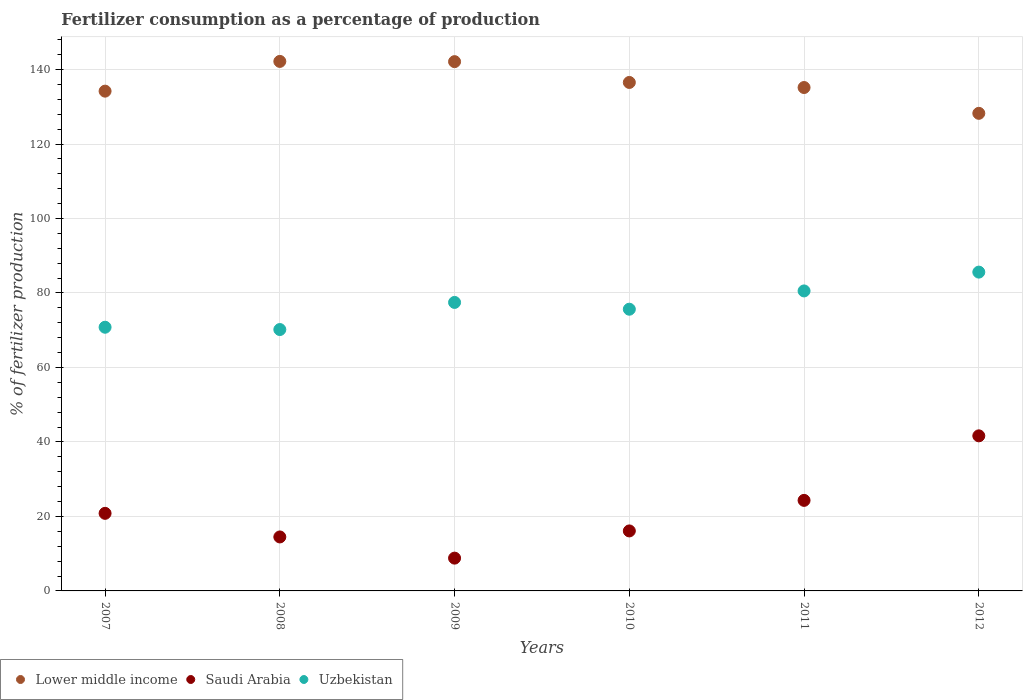Is the number of dotlines equal to the number of legend labels?
Offer a very short reply. Yes. What is the percentage of fertilizers consumed in Uzbekistan in 2008?
Your answer should be very brief. 70.18. Across all years, what is the maximum percentage of fertilizers consumed in Lower middle income?
Offer a very short reply. 142.18. Across all years, what is the minimum percentage of fertilizers consumed in Saudi Arabia?
Your response must be concise. 8.81. In which year was the percentage of fertilizers consumed in Saudi Arabia maximum?
Provide a succinct answer. 2012. What is the total percentage of fertilizers consumed in Uzbekistan in the graph?
Provide a succinct answer. 460.25. What is the difference between the percentage of fertilizers consumed in Saudi Arabia in 2009 and that in 2011?
Offer a very short reply. -15.51. What is the difference between the percentage of fertilizers consumed in Lower middle income in 2009 and the percentage of fertilizers consumed in Saudi Arabia in 2007?
Provide a short and direct response. 121.29. What is the average percentage of fertilizers consumed in Lower middle income per year?
Provide a succinct answer. 136.4. In the year 2011, what is the difference between the percentage of fertilizers consumed in Uzbekistan and percentage of fertilizers consumed in Saudi Arabia?
Ensure brevity in your answer.  56.24. What is the ratio of the percentage of fertilizers consumed in Saudi Arabia in 2007 to that in 2009?
Your answer should be very brief. 2.37. Is the percentage of fertilizers consumed in Uzbekistan in 2008 less than that in 2009?
Give a very brief answer. Yes. Is the difference between the percentage of fertilizers consumed in Uzbekistan in 2009 and 2010 greater than the difference between the percentage of fertilizers consumed in Saudi Arabia in 2009 and 2010?
Your answer should be compact. Yes. What is the difference between the highest and the second highest percentage of fertilizers consumed in Lower middle income?
Your answer should be compact. 0.06. What is the difference between the highest and the lowest percentage of fertilizers consumed in Lower middle income?
Make the answer very short. 13.94. Is the sum of the percentage of fertilizers consumed in Saudi Arabia in 2007 and 2012 greater than the maximum percentage of fertilizers consumed in Uzbekistan across all years?
Ensure brevity in your answer.  No. How many dotlines are there?
Offer a very short reply. 3. What is the difference between two consecutive major ticks on the Y-axis?
Your answer should be very brief. 20. Are the values on the major ticks of Y-axis written in scientific E-notation?
Provide a succinct answer. No. Does the graph contain grids?
Offer a very short reply. Yes. Where does the legend appear in the graph?
Keep it short and to the point. Bottom left. How many legend labels are there?
Your answer should be compact. 3. What is the title of the graph?
Your answer should be very brief. Fertilizer consumption as a percentage of production. Does "Paraguay" appear as one of the legend labels in the graph?
Provide a short and direct response. No. What is the label or title of the X-axis?
Make the answer very short. Years. What is the label or title of the Y-axis?
Provide a short and direct response. % of fertilizer production. What is the % of fertilizer production of Lower middle income in 2007?
Provide a short and direct response. 134.19. What is the % of fertilizer production of Saudi Arabia in 2007?
Give a very brief answer. 20.83. What is the % of fertilizer production in Uzbekistan in 2007?
Make the answer very short. 70.8. What is the % of fertilizer production in Lower middle income in 2008?
Your response must be concise. 142.18. What is the % of fertilizer production in Saudi Arabia in 2008?
Make the answer very short. 14.49. What is the % of fertilizer production in Uzbekistan in 2008?
Your answer should be very brief. 70.18. What is the % of fertilizer production in Lower middle income in 2009?
Your answer should be compact. 142.12. What is the % of fertilizer production of Saudi Arabia in 2009?
Your answer should be compact. 8.81. What is the % of fertilizer production of Uzbekistan in 2009?
Make the answer very short. 77.46. What is the % of fertilizer production of Lower middle income in 2010?
Provide a succinct answer. 136.53. What is the % of fertilizer production in Saudi Arabia in 2010?
Offer a terse response. 16.11. What is the % of fertilizer production in Uzbekistan in 2010?
Offer a terse response. 75.64. What is the % of fertilizer production in Lower middle income in 2011?
Offer a terse response. 135.17. What is the % of fertilizer production in Saudi Arabia in 2011?
Make the answer very short. 24.31. What is the % of fertilizer production in Uzbekistan in 2011?
Keep it short and to the point. 80.55. What is the % of fertilizer production in Lower middle income in 2012?
Make the answer very short. 128.24. What is the % of fertilizer production in Saudi Arabia in 2012?
Make the answer very short. 41.64. What is the % of fertilizer production in Uzbekistan in 2012?
Your answer should be very brief. 85.6. Across all years, what is the maximum % of fertilizer production of Lower middle income?
Provide a succinct answer. 142.18. Across all years, what is the maximum % of fertilizer production of Saudi Arabia?
Offer a terse response. 41.64. Across all years, what is the maximum % of fertilizer production of Uzbekistan?
Ensure brevity in your answer.  85.6. Across all years, what is the minimum % of fertilizer production in Lower middle income?
Make the answer very short. 128.24. Across all years, what is the minimum % of fertilizer production in Saudi Arabia?
Make the answer very short. 8.81. Across all years, what is the minimum % of fertilizer production in Uzbekistan?
Your response must be concise. 70.18. What is the total % of fertilizer production in Lower middle income in the graph?
Your answer should be very brief. 818.42. What is the total % of fertilizer production in Saudi Arabia in the graph?
Your answer should be compact. 126.19. What is the total % of fertilizer production of Uzbekistan in the graph?
Ensure brevity in your answer.  460.25. What is the difference between the % of fertilizer production in Lower middle income in 2007 and that in 2008?
Your answer should be very brief. -7.98. What is the difference between the % of fertilizer production in Saudi Arabia in 2007 and that in 2008?
Offer a terse response. 6.34. What is the difference between the % of fertilizer production in Uzbekistan in 2007 and that in 2008?
Make the answer very short. 0.62. What is the difference between the % of fertilizer production in Lower middle income in 2007 and that in 2009?
Your answer should be compact. -7.92. What is the difference between the % of fertilizer production in Saudi Arabia in 2007 and that in 2009?
Provide a succinct answer. 12.03. What is the difference between the % of fertilizer production in Uzbekistan in 2007 and that in 2009?
Your answer should be compact. -6.66. What is the difference between the % of fertilizer production of Lower middle income in 2007 and that in 2010?
Give a very brief answer. -2.33. What is the difference between the % of fertilizer production in Saudi Arabia in 2007 and that in 2010?
Provide a short and direct response. 4.72. What is the difference between the % of fertilizer production of Uzbekistan in 2007 and that in 2010?
Keep it short and to the point. -4.84. What is the difference between the % of fertilizer production in Lower middle income in 2007 and that in 2011?
Provide a short and direct response. -0.97. What is the difference between the % of fertilizer production of Saudi Arabia in 2007 and that in 2011?
Ensure brevity in your answer.  -3.48. What is the difference between the % of fertilizer production of Uzbekistan in 2007 and that in 2011?
Keep it short and to the point. -9.75. What is the difference between the % of fertilizer production in Lower middle income in 2007 and that in 2012?
Keep it short and to the point. 5.96. What is the difference between the % of fertilizer production of Saudi Arabia in 2007 and that in 2012?
Provide a short and direct response. -20.81. What is the difference between the % of fertilizer production in Uzbekistan in 2007 and that in 2012?
Make the answer very short. -14.8. What is the difference between the % of fertilizer production in Lower middle income in 2008 and that in 2009?
Your answer should be compact. 0.06. What is the difference between the % of fertilizer production of Saudi Arabia in 2008 and that in 2009?
Provide a succinct answer. 5.69. What is the difference between the % of fertilizer production of Uzbekistan in 2008 and that in 2009?
Give a very brief answer. -7.28. What is the difference between the % of fertilizer production of Lower middle income in 2008 and that in 2010?
Ensure brevity in your answer.  5.65. What is the difference between the % of fertilizer production of Saudi Arabia in 2008 and that in 2010?
Offer a very short reply. -1.62. What is the difference between the % of fertilizer production of Uzbekistan in 2008 and that in 2010?
Offer a very short reply. -5.46. What is the difference between the % of fertilizer production of Lower middle income in 2008 and that in 2011?
Offer a terse response. 7.01. What is the difference between the % of fertilizer production in Saudi Arabia in 2008 and that in 2011?
Provide a succinct answer. -9.82. What is the difference between the % of fertilizer production in Uzbekistan in 2008 and that in 2011?
Your answer should be very brief. -10.37. What is the difference between the % of fertilizer production in Lower middle income in 2008 and that in 2012?
Your answer should be very brief. 13.94. What is the difference between the % of fertilizer production in Saudi Arabia in 2008 and that in 2012?
Ensure brevity in your answer.  -27.15. What is the difference between the % of fertilizer production of Uzbekistan in 2008 and that in 2012?
Offer a terse response. -15.42. What is the difference between the % of fertilizer production in Lower middle income in 2009 and that in 2010?
Offer a terse response. 5.59. What is the difference between the % of fertilizer production of Saudi Arabia in 2009 and that in 2010?
Ensure brevity in your answer.  -7.3. What is the difference between the % of fertilizer production in Uzbekistan in 2009 and that in 2010?
Your answer should be very brief. 1.82. What is the difference between the % of fertilizer production in Lower middle income in 2009 and that in 2011?
Provide a short and direct response. 6.95. What is the difference between the % of fertilizer production of Saudi Arabia in 2009 and that in 2011?
Offer a terse response. -15.51. What is the difference between the % of fertilizer production of Uzbekistan in 2009 and that in 2011?
Your response must be concise. -3.09. What is the difference between the % of fertilizer production in Lower middle income in 2009 and that in 2012?
Provide a short and direct response. 13.88. What is the difference between the % of fertilizer production in Saudi Arabia in 2009 and that in 2012?
Your answer should be very brief. -32.83. What is the difference between the % of fertilizer production of Uzbekistan in 2009 and that in 2012?
Your response must be concise. -8.14. What is the difference between the % of fertilizer production in Lower middle income in 2010 and that in 2011?
Make the answer very short. 1.36. What is the difference between the % of fertilizer production of Saudi Arabia in 2010 and that in 2011?
Offer a very short reply. -8.2. What is the difference between the % of fertilizer production in Uzbekistan in 2010 and that in 2011?
Ensure brevity in your answer.  -4.91. What is the difference between the % of fertilizer production of Lower middle income in 2010 and that in 2012?
Provide a short and direct response. 8.29. What is the difference between the % of fertilizer production in Saudi Arabia in 2010 and that in 2012?
Offer a very short reply. -25.53. What is the difference between the % of fertilizer production in Uzbekistan in 2010 and that in 2012?
Provide a short and direct response. -9.96. What is the difference between the % of fertilizer production of Lower middle income in 2011 and that in 2012?
Provide a succinct answer. 6.93. What is the difference between the % of fertilizer production of Saudi Arabia in 2011 and that in 2012?
Keep it short and to the point. -17.33. What is the difference between the % of fertilizer production of Uzbekistan in 2011 and that in 2012?
Your answer should be very brief. -5.05. What is the difference between the % of fertilizer production of Lower middle income in 2007 and the % of fertilizer production of Saudi Arabia in 2008?
Provide a succinct answer. 119.7. What is the difference between the % of fertilizer production of Lower middle income in 2007 and the % of fertilizer production of Uzbekistan in 2008?
Keep it short and to the point. 64.01. What is the difference between the % of fertilizer production of Saudi Arabia in 2007 and the % of fertilizer production of Uzbekistan in 2008?
Your response must be concise. -49.35. What is the difference between the % of fertilizer production in Lower middle income in 2007 and the % of fertilizer production in Saudi Arabia in 2009?
Ensure brevity in your answer.  125.39. What is the difference between the % of fertilizer production in Lower middle income in 2007 and the % of fertilizer production in Uzbekistan in 2009?
Your response must be concise. 56.73. What is the difference between the % of fertilizer production of Saudi Arabia in 2007 and the % of fertilizer production of Uzbekistan in 2009?
Your answer should be compact. -56.63. What is the difference between the % of fertilizer production of Lower middle income in 2007 and the % of fertilizer production of Saudi Arabia in 2010?
Your answer should be compact. 118.08. What is the difference between the % of fertilizer production of Lower middle income in 2007 and the % of fertilizer production of Uzbekistan in 2010?
Keep it short and to the point. 58.55. What is the difference between the % of fertilizer production of Saudi Arabia in 2007 and the % of fertilizer production of Uzbekistan in 2010?
Keep it short and to the point. -54.81. What is the difference between the % of fertilizer production in Lower middle income in 2007 and the % of fertilizer production in Saudi Arabia in 2011?
Make the answer very short. 109.88. What is the difference between the % of fertilizer production of Lower middle income in 2007 and the % of fertilizer production of Uzbekistan in 2011?
Your answer should be very brief. 53.64. What is the difference between the % of fertilizer production in Saudi Arabia in 2007 and the % of fertilizer production in Uzbekistan in 2011?
Provide a short and direct response. -59.72. What is the difference between the % of fertilizer production of Lower middle income in 2007 and the % of fertilizer production of Saudi Arabia in 2012?
Your response must be concise. 92.55. What is the difference between the % of fertilizer production in Lower middle income in 2007 and the % of fertilizer production in Uzbekistan in 2012?
Give a very brief answer. 48.59. What is the difference between the % of fertilizer production in Saudi Arabia in 2007 and the % of fertilizer production in Uzbekistan in 2012?
Ensure brevity in your answer.  -64.77. What is the difference between the % of fertilizer production of Lower middle income in 2008 and the % of fertilizer production of Saudi Arabia in 2009?
Keep it short and to the point. 133.37. What is the difference between the % of fertilizer production of Lower middle income in 2008 and the % of fertilizer production of Uzbekistan in 2009?
Your answer should be very brief. 64.71. What is the difference between the % of fertilizer production in Saudi Arabia in 2008 and the % of fertilizer production in Uzbekistan in 2009?
Provide a succinct answer. -62.97. What is the difference between the % of fertilizer production of Lower middle income in 2008 and the % of fertilizer production of Saudi Arabia in 2010?
Keep it short and to the point. 126.07. What is the difference between the % of fertilizer production in Lower middle income in 2008 and the % of fertilizer production in Uzbekistan in 2010?
Offer a very short reply. 66.54. What is the difference between the % of fertilizer production of Saudi Arabia in 2008 and the % of fertilizer production of Uzbekistan in 2010?
Your answer should be very brief. -61.15. What is the difference between the % of fertilizer production in Lower middle income in 2008 and the % of fertilizer production in Saudi Arabia in 2011?
Give a very brief answer. 117.87. What is the difference between the % of fertilizer production in Lower middle income in 2008 and the % of fertilizer production in Uzbekistan in 2011?
Your answer should be compact. 61.63. What is the difference between the % of fertilizer production of Saudi Arabia in 2008 and the % of fertilizer production of Uzbekistan in 2011?
Offer a terse response. -66.06. What is the difference between the % of fertilizer production of Lower middle income in 2008 and the % of fertilizer production of Saudi Arabia in 2012?
Your answer should be compact. 100.54. What is the difference between the % of fertilizer production of Lower middle income in 2008 and the % of fertilizer production of Uzbekistan in 2012?
Offer a terse response. 56.57. What is the difference between the % of fertilizer production of Saudi Arabia in 2008 and the % of fertilizer production of Uzbekistan in 2012?
Offer a terse response. -71.11. What is the difference between the % of fertilizer production of Lower middle income in 2009 and the % of fertilizer production of Saudi Arabia in 2010?
Your response must be concise. 126.01. What is the difference between the % of fertilizer production of Lower middle income in 2009 and the % of fertilizer production of Uzbekistan in 2010?
Make the answer very short. 66.48. What is the difference between the % of fertilizer production of Saudi Arabia in 2009 and the % of fertilizer production of Uzbekistan in 2010?
Keep it short and to the point. -66.84. What is the difference between the % of fertilizer production of Lower middle income in 2009 and the % of fertilizer production of Saudi Arabia in 2011?
Your answer should be very brief. 117.8. What is the difference between the % of fertilizer production in Lower middle income in 2009 and the % of fertilizer production in Uzbekistan in 2011?
Your response must be concise. 61.57. What is the difference between the % of fertilizer production in Saudi Arabia in 2009 and the % of fertilizer production in Uzbekistan in 2011?
Offer a terse response. -71.75. What is the difference between the % of fertilizer production of Lower middle income in 2009 and the % of fertilizer production of Saudi Arabia in 2012?
Ensure brevity in your answer.  100.48. What is the difference between the % of fertilizer production of Lower middle income in 2009 and the % of fertilizer production of Uzbekistan in 2012?
Keep it short and to the point. 56.51. What is the difference between the % of fertilizer production of Saudi Arabia in 2009 and the % of fertilizer production of Uzbekistan in 2012?
Keep it short and to the point. -76.8. What is the difference between the % of fertilizer production in Lower middle income in 2010 and the % of fertilizer production in Saudi Arabia in 2011?
Provide a succinct answer. 112.22. What is the difference between the % of fertilizer production in Lower middle income in 2010 and the % of fertilizer production in Uzbekistan in 2011?
Provide a short and direct response. 55.98. What is the difference between the % of fertilizer production in Saudi Arabia in 2010 and the % of fertilizer production in Uzbekistan in 2011?
Make the answer very short. -64.44. What is the difference between the % of fertilizer production in Lower middle income in 2010 and the % of fertilizer production in Saudi Arabia in 2012?
Your answer should be compact. 94.89. What is the difference between the % of fertilizer production in Lower middle income in 2010 and the % of fertilizer production in Uzbekistan in 2012?
Your answer should be compact. 50.92. What is the difference between the % of fertilizer production in Saudi Arabia in 2010 and the % of fertilizer production in Uzbekistan in 2012?
Offer a very short reply. -69.49. What is the difference between the % of fertilizer production of Lower middle income in 2011 and the % of fertilizer production of Saudi Arabia in 2012?
Your response must be concise. 93.53. What is the difference between the % of fertilizer production in Lower middle income in 2011 and the % of fertilizer production in Uzbekistan in 2012?
Provide a short and direct response. 49.56. What is the difference between the % of fertilizer production of Saudi Arabia in 2011 and the % of fertilizer production of Uzbekistan in 2012?
Give a very brief answer. -61.29. What is the average % of fertilizer production in Lower middle income per year?
Ensure brevity in your answer.  136.4. What is the average % of fertilizer production in Saudi Arabia per year?
Your answer should be very brief. 21.03. What is the average % of fertilizer production of Uzbekistan per year?
Provide a short and direct response. 76.71. In the year 2007, what is the difference between the % of fertilizer production of Lower middle income and % of fertilizer production of Saudi Arabia?
Provide a short and direct response. 113.36. In the year 2007, what is the difference between the % of fertilizer production in Lower middle income and % of fertilizer production in Uzbekistan?
Your response must be concise. 63.39. In the year 2007, what is the difference between the % of fertilizer production of Saudi Arabia and % of fertilizer production of Uzbekistan?
Provide a short and direct response. -49.97. In the year 2008, what is the difference between the % of fertilizer production in Lower middle income and % of fertilizer production in Saudi Arabia?
Give a very brief answer. 127.68. In the year 2008, what is the difference between the % of fertilizer production in Lower middle income and % of fertilizer production in Uzbekistan?
Make the answer very short. 72. In the year 2008, what is the difference between the % of fertilizer production of Saudi Arabia and % of fertilizer production of Uzbekistan?
Keep it short and to the point. -55.69. In the year 2009, what is the difference between the % of fertilizer production of Lower middle income and % of fertilizer production of Saudi Arabia?
Provide a succinct answer. 133.31. In the year 2009, what is the difference between the % of fertilizer production in Lower middle income and % of fertilizer production in Uzbekistan?
Give a very brief answer. 64.65. In the year 2009, what is the difference between the % of fertilizer production of Saudi Arabia and % of fertilizer production of Uzbekistan?
Offer a terse response. -68.66. In the year 2010, what is the difference between the % of fertilizer production in Lower middle income and % of fertilizer production in Saudi Arabia?
Your answer should be compact. 120.42. In the year 2010, what is the difference between the % of fertilizer production in Lower middle income and % of fertilizer production in Uzbekistan?
Your response must be concise. 60.89. In the year 2010, what is the difference between the % of fertilizer production in Saudi Arabia and % of fertilizer production in Uzbekistan?
Offer a very short reply. -59.53. In the year 2011, what is the difference between the % of fertilizer production in Lower middle income and % of fertilizer production in Saudi Arabia?
Your response must be concise. 110.86. In the year 2011, what is the difference between the % of fertilizer production of Lower middle income and % of fertilizer production of Uzbekistan?
Your answer should be very brief. 54.62. In the year 2011, what is the difference between the % of fertilizer production in Saudi Arabia and % of fertilizer production in Uzbekistan?
Offer a very short reply. -56.24. In the year 2012, what is the difference between the % of fertilizer production of Lower middle income and % of fertilizer production of Saudi Arabia?
Ensure brevity in your answer.  86.6. In the year 2012, what is the difference between the % of fertilizer production of Lower middle income and % of fertilizer production of Uzbekistan?
Offer a terse response. 42.63. In the year 2012, what is the difference between the % of fertilizer production in Saudi Arabia and % of fertilizer production in Uzbekistan?
Ensure brevity in your answer.  -43.96. What is the ratio of the % of fertilizer production of Lower middle income in 2007 to that in 2008?
Offer a very short reply. 0.94. What is the ratio of the % of fertilizer production of Saudi Arabia in 2007 to that in 2008?
Make the answer very short. 1.44. What is the ratio of the % of fertilizer production of Uzbekistan in 2007 to that in 2008?
Provide a short and direct response. 1.01. What is the ratio of the % of fertilizer production of Lower middle income in 2007 to that in 2009?
Offer a very short reply. 0.94. What is the ratio of the % of fertilizer production in Saudi Arabia in 2007 to that in 2009?
Provide a succinct answer. 2.37. What is the ratio of the % of fertilizer production in Uzbekistan in 2007 to that in 2009?
Ensure brevity in your answer.  0.91. What is the ratio of the % of fertilizer production in Lower middle income in 2007 to that in 2010?
Your answer should be very brief. 0.98. What is the ratio of the % of fertilizer production in Saudi Arabia in 2007 to that in 2010?
Your response must be concise. 1.29. What is the ratio of the % of fertilizer production of Uzbekistan in 2007 to that in 2010?
Ensure brevity in your answer.  0.94. What is the ratio of the % of fertilizer production of Lower middle income in 2007 to that in 2011?
Ensure brevity in your answer.  0.99. What is the ratio of the % of fertilizer production in Saudi Arabia in 2007 to that in 2011?
Make the answer very short. 0.86. What is the ratio of the % of fertilizer production of Uzbekistan in 2007 to that in 2011?
Offer a terse response. 0.88. What is the ratio of the % of fertilizer production in Lower middle income in 2007 to that in 2012?
Provide a succinct answer. 1.05. What is the ratio of the % of fertilizer production in Saudi Arabia in 2007 to that in 2012?
Provide a succinct answer. 0.5. What is the ratio of the % of fertilizer production of Uzbekistan in 2007 to that in 2012?
Your answer should be very brief. 0.83. What is the ratio of the % of fertilizer production of Saudi Arabia in 2008 to that in 2009?
Offer a very short reply. 1.65. What is the ratio of the % of fertilizer production of Uzbekistan in 2008 to that in 2009?
Provide a short and direct response. 0.91. What is the ratio of the % of fertilizer production in Lower middle income in 2008 to that in 2010?
Ensure brevity in your answer.  1.04. What is the ratio of the % of fertilizer production of Saudi Arabia in 2008 to that in 2010?
Your response must be concise. 0.9. What is the ratio of the % of fertilizer production of Uzbekistan in 2008 to that in 2010?
Your answer should be very brief. 0.93. What is the ratio of the % of fertilizer production of Lower middle income in 2008 to that in 2011?
Provide a succinct answer. 1.05. What is the ratio of the % of fertilizer production of Saudi Arabia in 2008 to that in 2011?
Provide a succinct answer. 0.6. What is the ratio of the % of fertilizer production of Uzbekistan in 2008 to that in 2011?
Offer a very short reply. 0.87. What is the ratio of the % of fertilizer production in Lower middle income in 2008 to that in 2012?
Provide a short and direct response. 1.11. What is the ratio of the % of fertilizer production in Saudi Arabia in 2008 to that in 2012?
Offer a very short reply. 0.35. What is the ratio of the % of fertilizer production of Uzbekistan in 2008 to that in 2012?
Your response must be concise. 0.82. What is the ratio of the % of fertilizer production of Lower middle income in 2009 to that in 2010?
Offer a terse response. 1.04. What is the ratio of the % of fertilizer production of Saudi Arabia in 2009 to that in 2010?
Keep it short and to the point. 0.55. What is the ratio of the % of fertilizer production in Uzbekistan in 2009 to that in 2010?
Keep it short and to the point. 1.02. What is the ratio of the % of fertilizer production in Lower middle income in 2009 to that in 2011?
Your response must be concise. 1.05. What is the ratio of the % of fertilizer production in Saudi Arabia in 2009 to that in 2011?
Offer a very short reply. 0.36. What is the ratio of the % of fertilizer production in Uzbekistan in 2009 to that in 2011?
Your answer should be compact. 0.96. What is the ratio of the % of fertilizer production in Lower middle income in 2009 to that in 2012?
Offer a terse response. 1.11. What is the ratio of the % of fertilizer production in Saudi Arabia in 2009 to that in 2012?
Ensure brevity in your answer.  0.21. What is the ratio of the % of fertilizer production of Uzbekistan in 2009 to that in 2012?
Offer a terse response. 0.9. What is the ratio of the % of fertilizer production of Saudi Arabia in 2010 to that in 2011?
Provide a short and direct response. 0.66. What is the ratio of the % of fertilizer production of Uzbekistan in 2010 to that in 2011?
Give a very brief answer. 0.94. What is the ratio of the % of fertilizer production of Lower middle income in 2010 to that in 2012?
Provide a short and direct response. 1.06. What is the ratio of the % of fertilizer production of Saudi Arabia in 2010 to that in 2012?
Make the answer very short. 0.39. What is the ratio of the % of fertilizer production in Uzbekistan in 2010 to that in 2012?
Your response must be concise. 0.88. What is the ratio of the % of fertilizer production of Lower middle income in 2011 to that in 2012?
Your answer should be compact. 1.05. What is the ratio of the % of fertilizer production of Saudi Arabia in 2011 to that in 2012?
Offer a very short reply. 0.58. What is the ratio of the % of fertilizer production of Uzbekistan in 2011 to that in 2012?
Your answer should be compact. 0.94. What is the difference between the highest and the second highest % of fertilizer production of Lower middle income?
Ensure brevity in your answer.  0.06. What is the difference between the highest and the second highest % of fertilizer production in Saudi Arabia?
Your answer should be compact. 17.33. What is the difference between the highest and the second highest % of fertilizer production in Uzbekistan?
Your answer should be compact. 5.05. What is the difference between the highest and the lowest % of fertilizer production of Lower middle income?
Make the answer very short. 13.94. What is the difference between the highest and the lowest % of fertilizer production of Saudi Arabia?
Your answer should be very brief. 32.83. What is the difference between the highest and the lowest % of fertilizer production in Uzbekistan?
Make the answer very short. 15.42. 